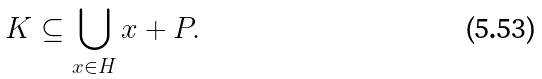Convert formula to latex. <formula><loc_0><loc_0><loc_500><loc_500>K \subseteq \bigcup _ { x \in H } x + P .</formula> 